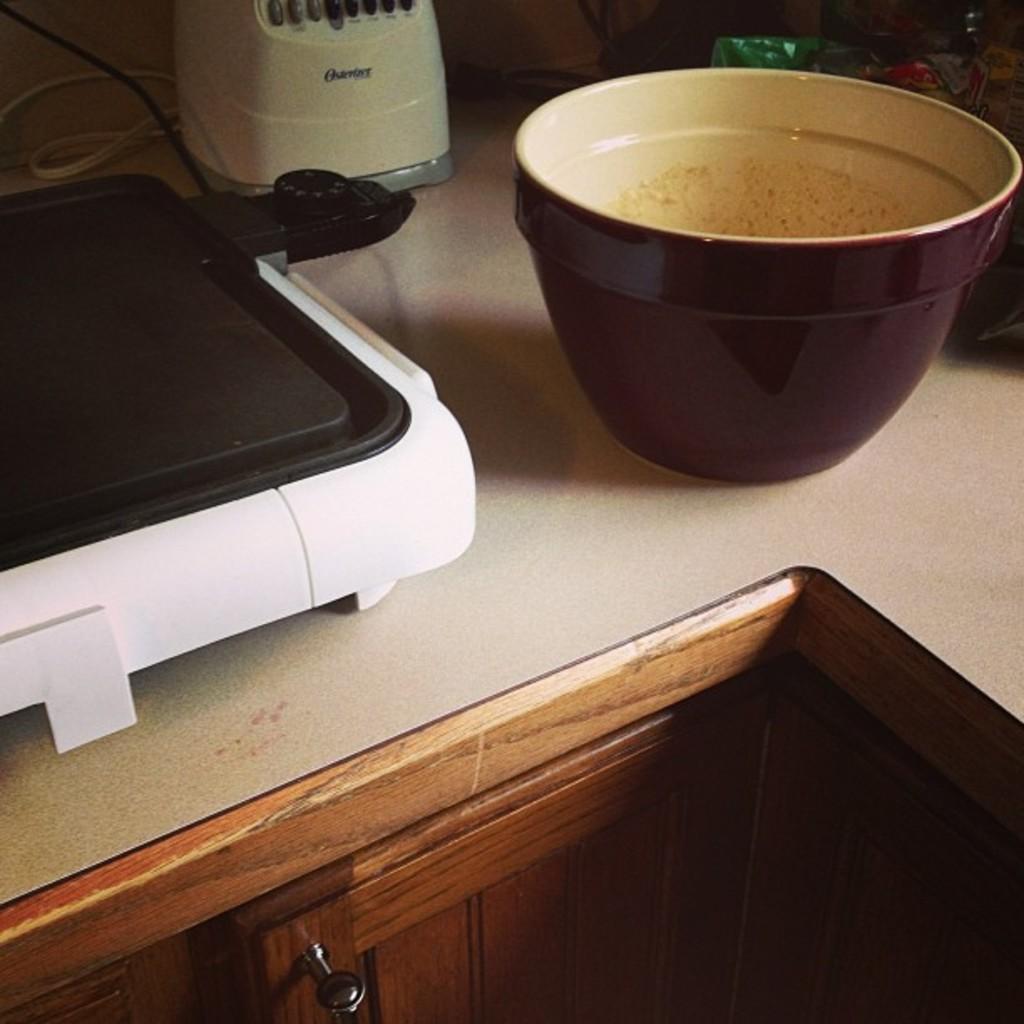This coffee and coffee maker?
Offer a terse response. No. 